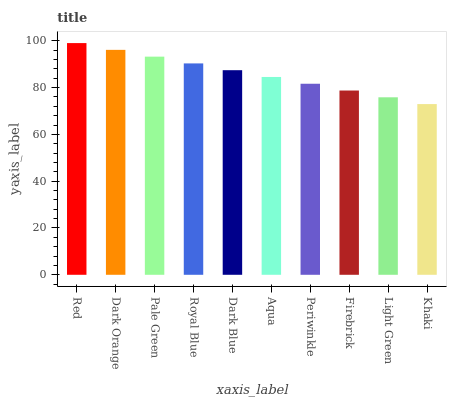Is Dark Orange the minimum?
Answer yes or no. No. Is Dark Orange the maximum?
Answer yes or no. No. Is Red greater than Dark Orange?
Answer yes or no. Yes. Is Dark Orange less than Red?
Answer yes or no. Yes. Is Dark Orange greater than Red?
Answer yes or no. No. Is Red less than Dark Orange?
Answer yes or no. No. Is Dark Blue the high median?
Answer yes or no. Yes. Is Aqua the low median?
Answer yes or no. Yes. Is Royal Blue the high median?
Answer yes or no. No. Is Firebrick the low median?
Answer yes or no. No. 